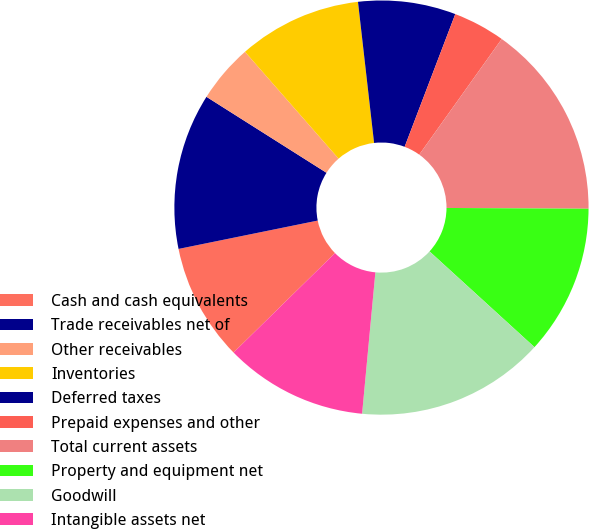Convert chart. <chart><loc_0><loc_0><loc_500><loc_500><pie_chart><fcel>Cash and cash equivalents<fcel>Trade receivables net of<fcel>Other receivables<fcel>Inventories<fcel>Deferred taxes<fcel>Prepaid expenses and other<fcel>Total current assets<fcel>Property and equipment net<fcel>Goodwill<fcel>Intangible assets net<nl><fcel>9.14%<fcel>12.18%<fcel>4.57%<fcel>9.64%<fcel>7.61%<fcel>4.06%<fcel>15.23%<fcel>11.68%<fcel>14.72%<fcel>11.17%<nl></chart> 